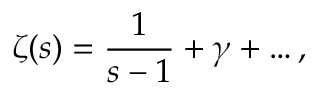Convert formula to latex. <formula><loc_0><loc_0><loc_500><loc_500>\zeta ( s ) = \frac { 1 } { s - 1 } + \gamma + \dots ,</formula> 